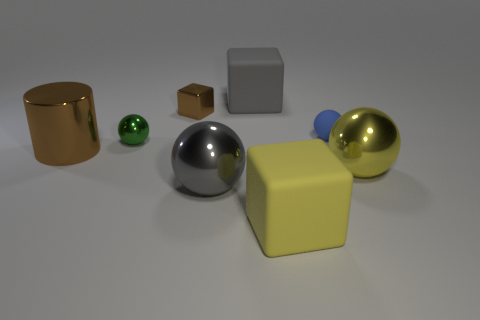Subtract all rubber blocks. How many blocks are left? 1 Add 2 brown metal objects. How many objects exist? 10 Subtract all cubes. How many objects are left? 5 Subtract 3 balls. How many balls are left? 1 Subtract all red cubes. Subtract all blue cylinders. How many cubes are left? 3 Subtract all small gray rubber cylinders. Subtract all tiny metal spheres. How many objects are left? 7 Add 1 metal balls. How many metal balls are left? 4 Add 6 brown metal cubes. How many brown metal cubes exist? 7 Subtract all gray cubes. How many cubes are left? 2 Subtract 0 brown balls. How many objects are left? 8 